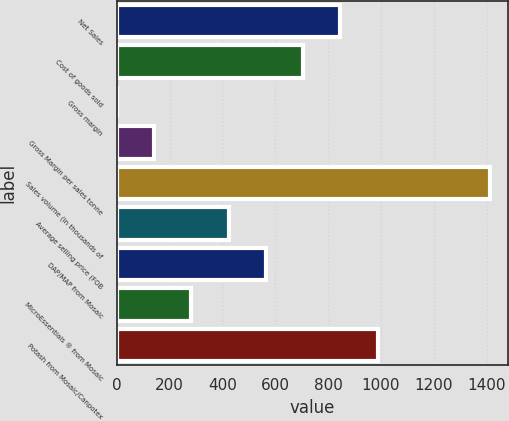<chart> <loc_0><loc_0><loc_500><loc_500><bar_chart><fcel>Net Sales<fcel>Cost of goods sold<fcel>Gross margin<fcel>Gross Margin per sales tonne<fcel>Sales volume (in thousands of<fcel>Average selling price (FOB<fcel>DAP/MAP from Mosaic<fcel>MicroEssentials ® from Mosaic<fcel>Potash from Mosaic/Canpotex<nl><fcel>846.84<fcel>705.8<fcel>0.6<fcel>141.64<fcel>1411<fcel>423.72<fcel>564.76<fcel>282.68<fcel>987.88<nl></chart> 